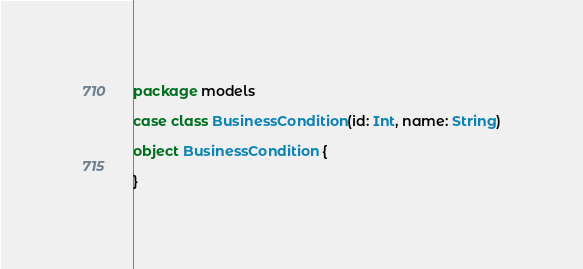<code> <loc_0><loc_0><loc_500><loc_500><_Scala_>package models

case class BusinessCondition(id: Int, name: String)

object BusinessCondition {

}
</code> 